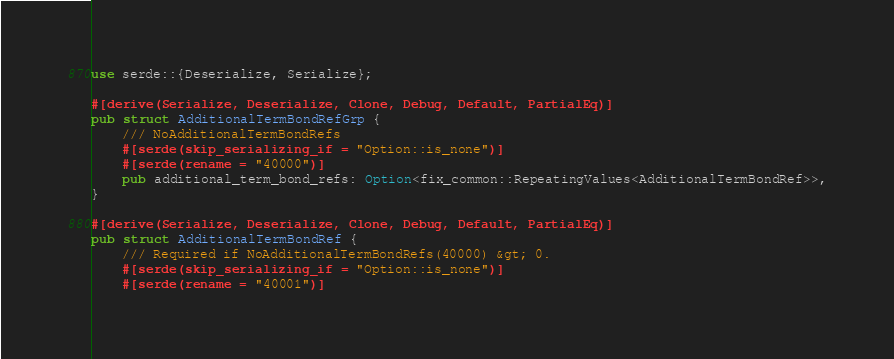Convert code to text. <code><loc_0><loc_0><loc_500><loc_500><_Rust_>
use serde::{Deserialize, Serialize};

#[derive(Serialize, Deserialize, Clone, Debug, Default, PartialEq)]
pub struct AdditionalTermBondRefGrp {
	/// NoAdditionalTermBondRefs
	#[serde(skip_serializing_if = "Option::is_none")]
	#[serde(rename = "40000")]
	pub additional_term_bond_refs: Option<fix_common::RepeatingValues<AdditionalTermBondRef>>,
}

#[derive(Serialize, Deserialize, Clone, Debug, Default, PartialEq)]
pub struct AdditionalTermBondRef {
	/// Required if NoAdditionalTermBondRefs(40000) &gt; 0.
	#[serde(skip_serializing_if = "Option::is_none")]
	#[serde(rename = "40001")]</code> 